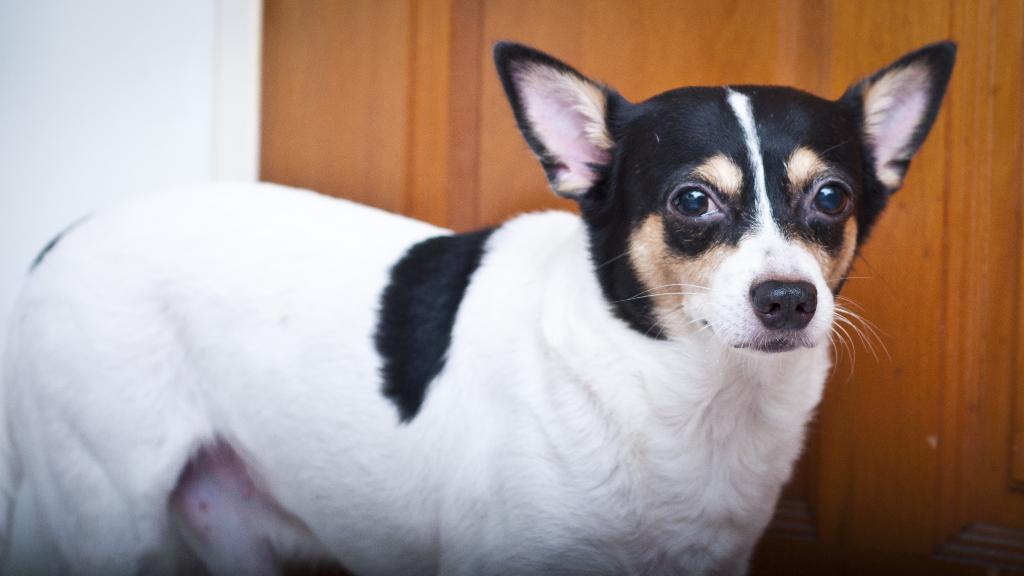In one or two sentences, can you explain what this image depicts? In the foreground of the image there is a dog. In the background of the image there is wall. There is a wooden door. 